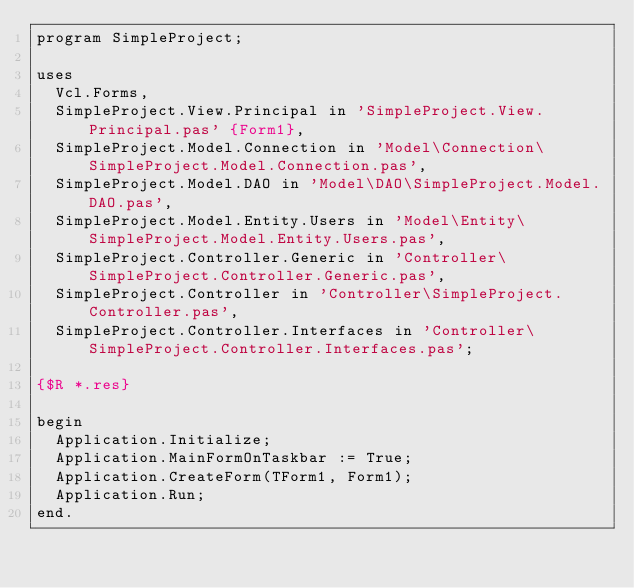<code> <loc_0><loc_0><loc_500><loc_500><_Pascal_>program SimpleProject;

uses
  Vcl.Forms,
  SimpleProject.View.Principal in 'SimpleProject.View.Principal.pas' {Form1},
  SimpleProject.Model.Connection in 'Model\Connection\SimpleProject.Model.Connection.pas',
  SimpleProject.Model.DAO in 'Model\DAO\SimpleProject.Model.DAO.pas',
  SimpleProject.Model.Entity.Users in 'Model\Entity\SimpleProject.Model.Entity.Users.pas',
  SimpleProject.Controller.Generic in 'Controller\SimpleProject.Controller.Generic.pas',
  SimpleProject.Controller in 'Controller\SimpleProject.Controller.pas',
  SimpleProject.Controller.Interfaces in 'Controller\SimpleProject.Controller.Interfaces.pas';

{$R *.res}

begin
  Application.Initialize;
  Application.MainFormOnTaskbar := True;
  Application.CreateForm(TForm1, Form1);
  Application.Run;
end.
</code> 